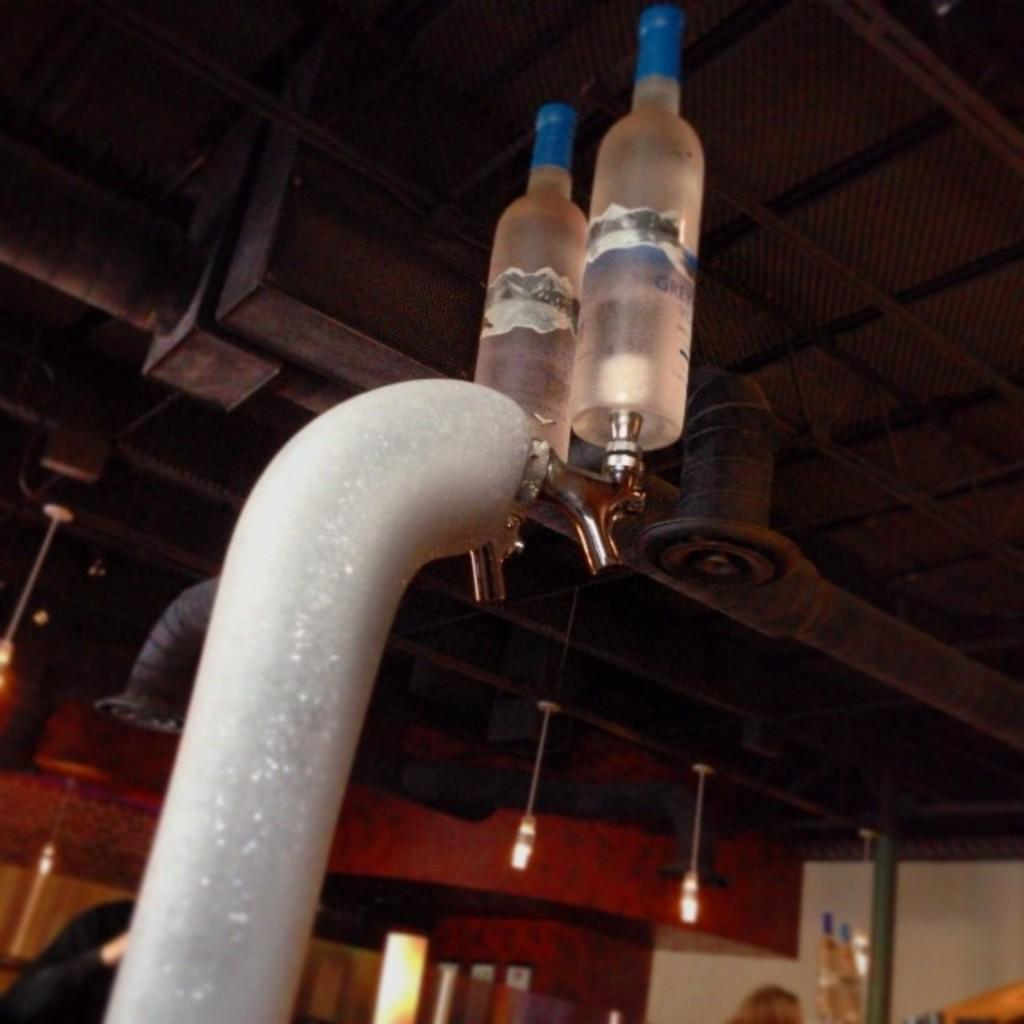What can be seen in the image related to water flow? There is a pipe with two taps in the image. What is placed on top of the taps? There are bottles on top of the taps. What can be seen in the background of the image? There are lights, a pole, and a wall in the background of the image. How many balls are being juggled by the person in the image? There is no person or balls present in the image. What type of van can be seen parked near the pole in the image? There is no van present in the image; only a pole and a wall are visible in the background. 